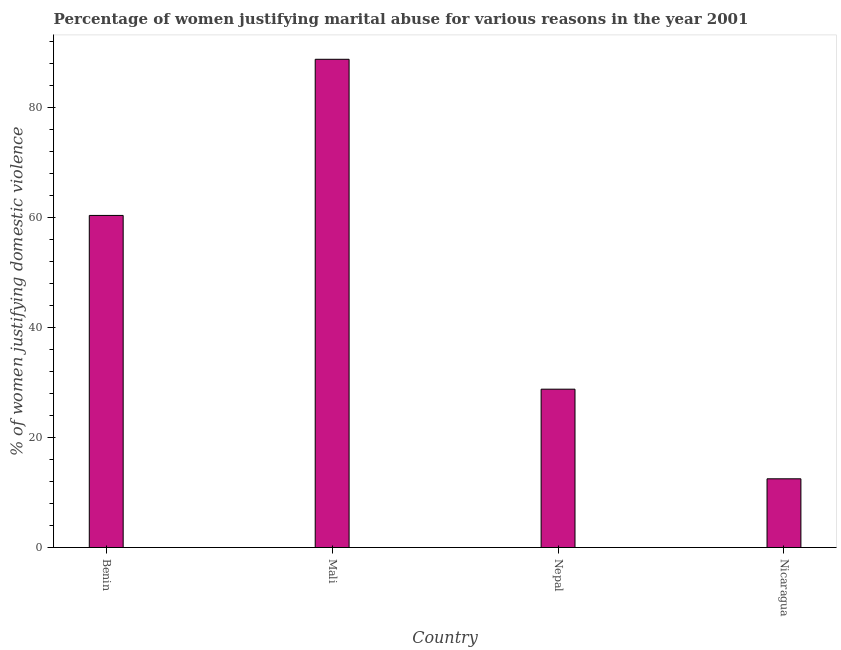Does the graph contain any zero values?
Your answer should be very brief. No. Does the graph contain grids?
Your answer should be compact. No. What is the title of the graph?
Ensure brevity in your answer.  Percentage of women justifying marital abuse for various reasons in the year 2001. What is the label or title of the Y-axis?
Your answer should be compact. % of women justifying domestic violence. What is the percentage of women justifying marital abuse in Nepal?
Make the answer very short. 28.8. Across all countries, what is the maximum percentage of women justifying marital abuse?
Give a very brief answer. 88.8. In which country was the percentage of women justifying marital abuse maximum?
Keep it short and to the point. Mali. In which country was the percentage of women justifying marital abuse minimum?
Ensure brevity in your answer.  Nicaragua. What is the sum of the percentage of women justifying marital abuse?
Give a very brief answer. 190.5. What is the difference between the percentage of women justifying marital abuse in Benin and Nicaragua?
Your answer should be very brief. 47.9. What is the average percentage of women justifying marital abuse per country?
Your answer should be compact. 47.62. What is the median percentage of women justifying marital abuse?
Offer a very short reply. 44.6. What is the ratio of the percentage of women justifying marital abuse in Mali to that in Nicaragua?
Give a very brief answer. 7.1. Is the percentage of women justifying marital abuse in Benin less than that in Nicaragua?
Offer a terse response. No. What is the difference between the highest and the second highest percentage of women justifying marital abuse?
Your response must be concise. 28.4. What is the difference between the highest and the lowest percentage of women justifying marital abuse?
Your answer should be compact. 76.3. In how many countries, is the percentage of women justifying marital abuse greater than the average percentage of women justifying marital abuse taken over all countries?
Provide a short and direct response. 2. How many bars are there?
Give a very brief answer. 4. Are all the bars in the graph horizontal?
Offer a very short reply. No. Are the values on the major ticks of Y-axis written in scientific E-notation?
Your answer should be very brief. No. What is the % of women justifying domestic violence of Benin?
Offer a very short reply. 60.4. What is the % of women justifying domestic violence in Mali?
Your response must be concise. 88.8. What is the % of women justifying domestic violence in Nepal?
Keep it short and to the point. 28.8. What is the difference between the % of women justifying domestic violence in Benin and Mali?
Offer a terse response. -28.4. What is the difference between the % of women justifying domestic violence in Benin and Nepal?
Make the answer very short. 31.6. What is the difference between the % of women justifying domestic violence in Benin and Nicaragua?
Your response must be concise. 47.9. What is the difference between the % of women justifying domestic violence in Mali and Nepal?
Make the answer very short. 60. What is the difference between the % of women justifying domestic violence in Mali and Nicaragua?
Give a very brief answer. 76.3. What is the difference between the % of women justifying domestic violence in Nepal and Nicaragua?
Offer a very short reply. 16.3. What is the ratio of the % of women justifying domestic violence in Benin to that in Mali?
Offer a very short reply. 0.68. What is the ratio of the % of women justifying domestic violence in Benin to that in Nepal?
Provide a succinct answer. 2.1. What is the ratio of the % of women justifying domestic violence in Benin to that in Nicaragua?
Ensure brevity in your answer.  4.83. What is the ratio of the % of women justifying domestic violence in Mali to that in Nepal?
Your answer should be very brief. 3.08. What is the ratio of the % of women justifying domestic violence in Mali to that in Nicaragua?
Give a very brief answer. 7.1. What is the ratio of the % of women justifying domestic violence in Nepal to that in Nicaragua?
Ensure brevity in your answer.  2.3. 